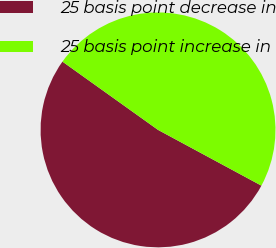<chart> <loc_0><loc_0><loc_500><loc_500><pie_chart><fcel>25 basis point decrease in<fcel>25 basis point increase in<nl><fcel>52.0%<fcel>48.0%<nl></chart> 